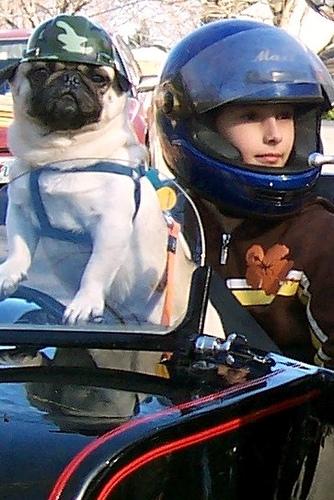Where is the dog?
Quick response, please. On car. Is the child wearing protective headgear?
Give a very brief answer. Yes. What breed is this dog?
Write a very short answer. Pug. How many people are wearing helmets?
Concise answer only. 1. 